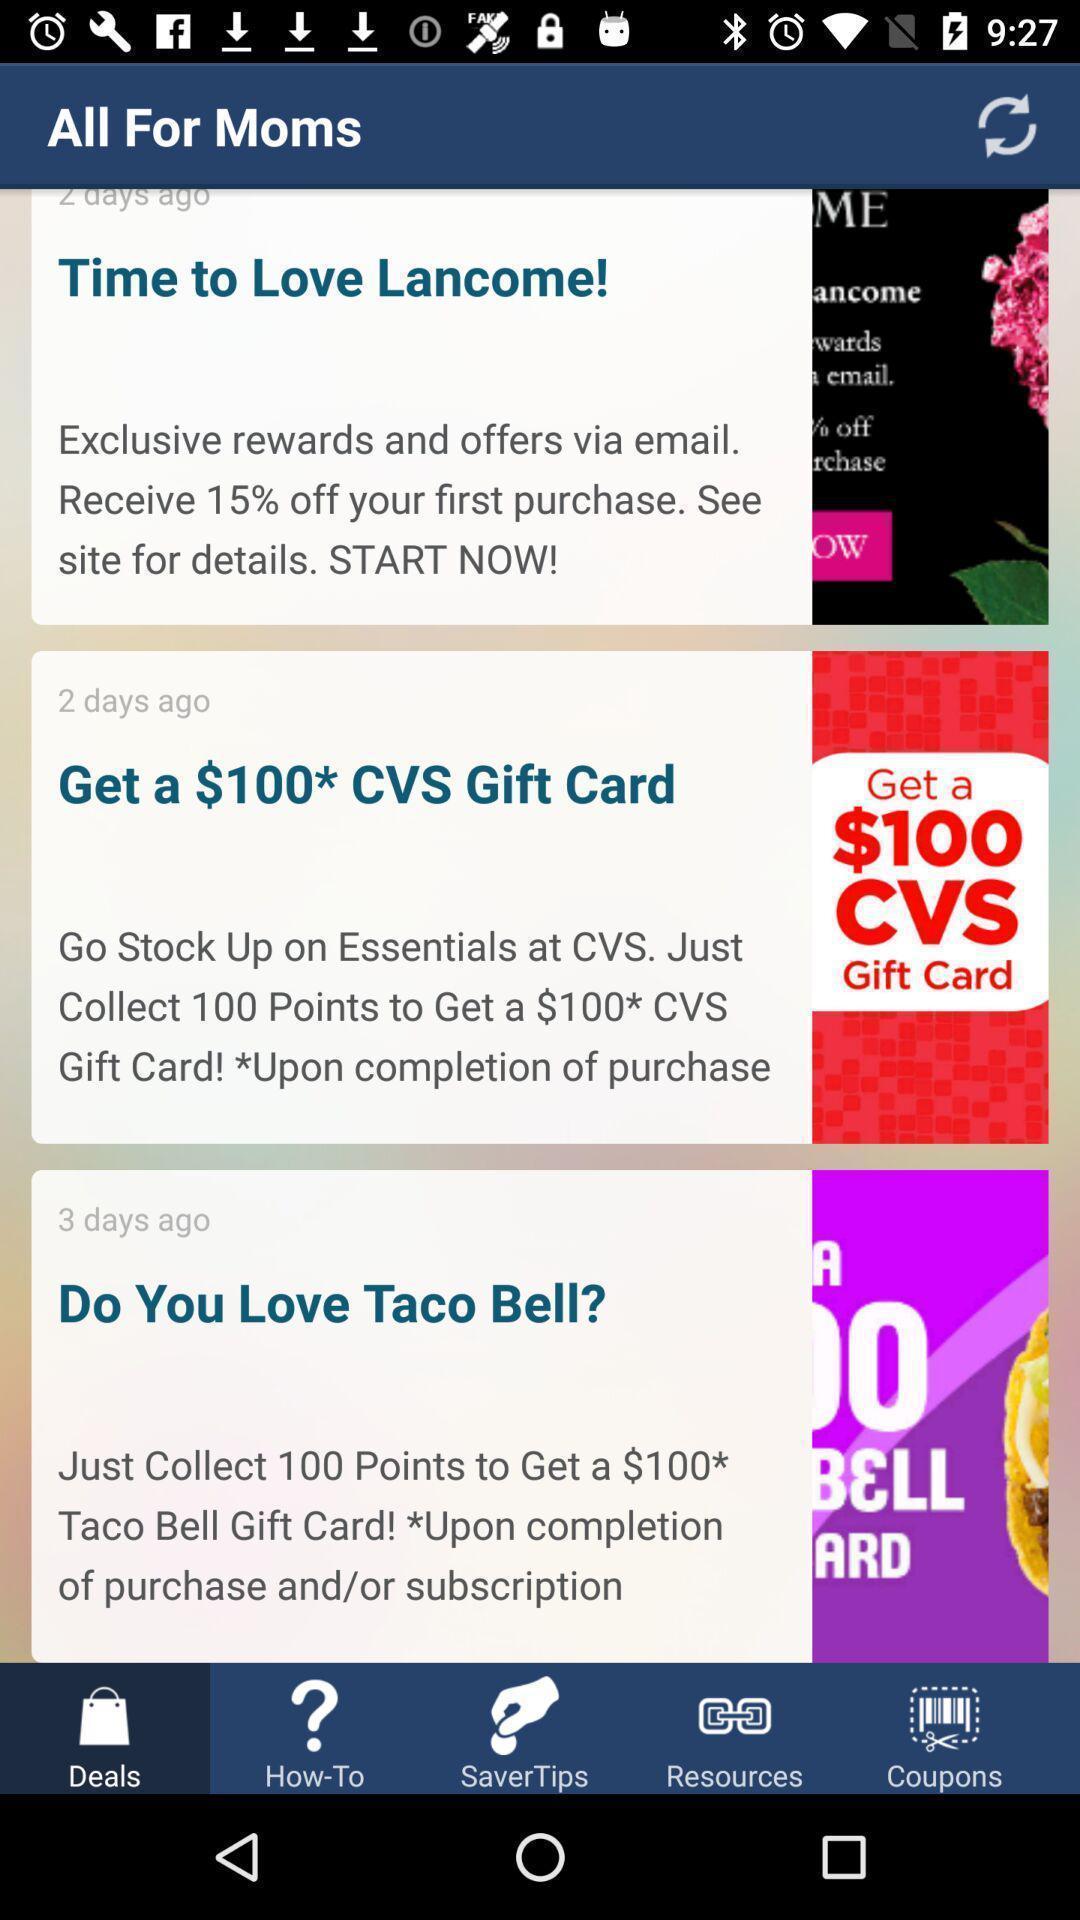Tell me what you see in this picture. Page displaying for food app. 